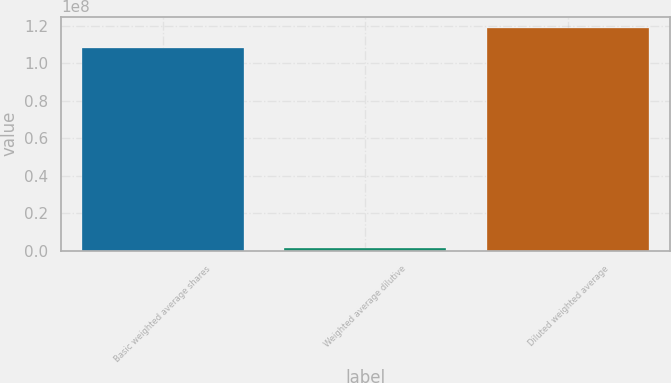Convert chart. <chart><loc_0><loc_0><loc_500><loc_500><bar_chart><fcel>Basic weighted average shares<fcel>Weighted average dilutive<fcel>Diluted weighted average<nl><fcel>1.08278e+08<fcel>1.53728e+06<fcel>1.19106e+08<nl></chart> 